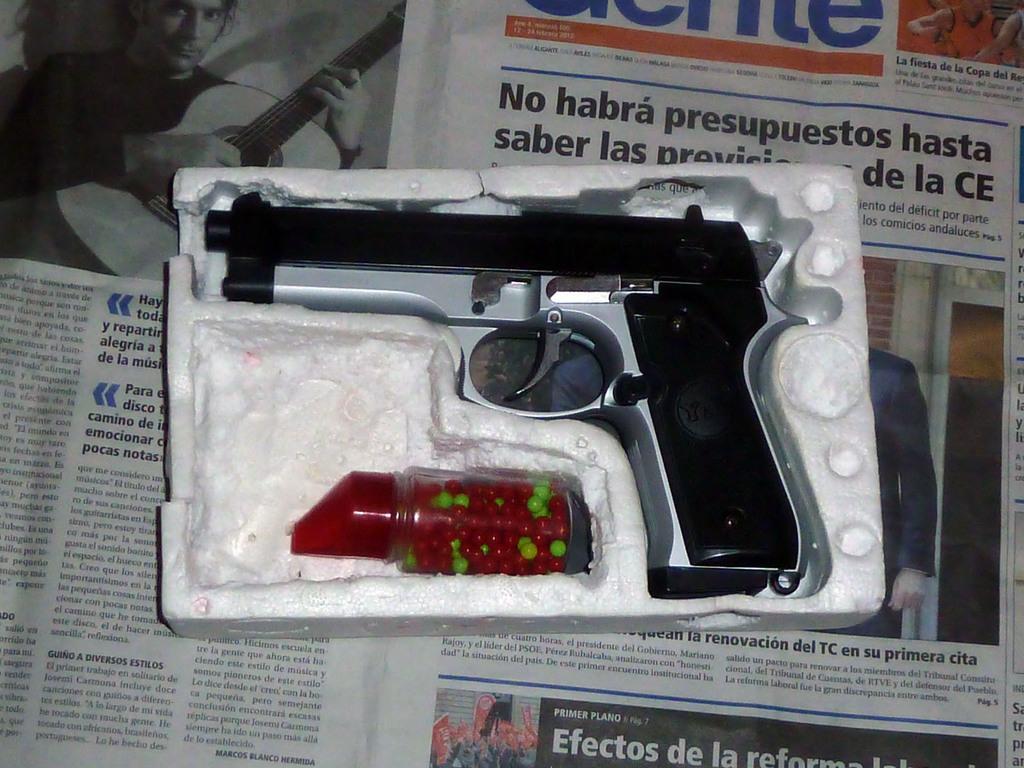Can you describe this image briefly? In this picture I can see a gun with few bullets in a bottle and a newspaper under it. 